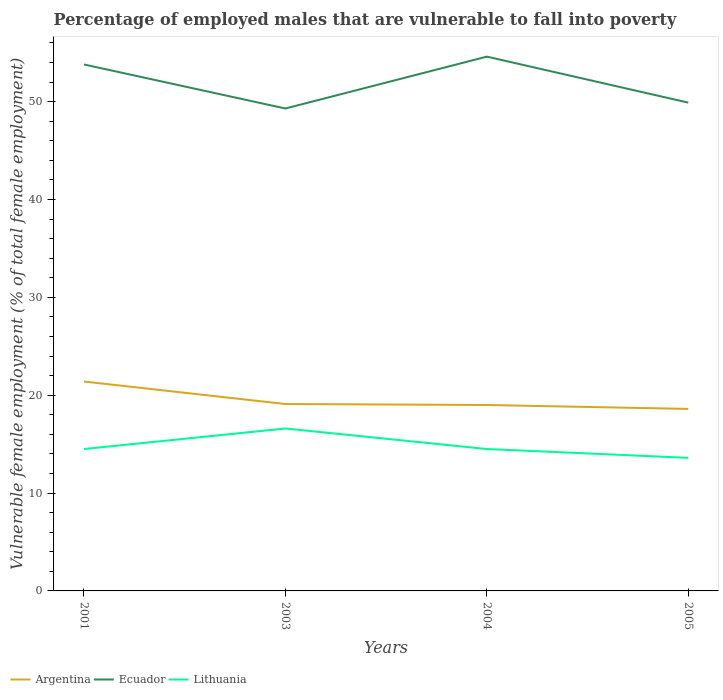Is the number of lines equal to the number of legend labels?
Make the answer very short. Yes. Across all years, what is the maximum percentage of employed males who are vulnerable to fall into poverty in Lithuania?
Your answer should be compact. 13.6. In which year was the percentage of employed males who are vulnerable to fall into poverty in Ecuador maximum?
Keep it short and to the point. 2003. What is the total percentage of employed males who are vulnerable to fall into poverty in Lithuania in the graph?
Keep it short and to the point. 0.9. What is the difference between the highest and the second highest percentage of employed males who are vulnerable to fall into poverty in Lithuania?
Your answer should be very brief. 3. What is the difference between the highest and the lowest percentage of employed males who are vulnerable to fall into poverty in Argentina?
Provide a short and direct response. 1. How many lines are there?
Your answer should be compact. 3. Does the graph contain grids?
Give a very brief answer. No. Where does the legend appear in the graph?
Your answer should be very brief. Bottom left. How are the legend labels stacked?
Provide a short and direct response. Horizontal. What is the title of the graph?
Offer a very short reply. Percentage of employed males that are vulnerable to fall into poverty. What is the label or title of the Y-axis?
Give a very brief answer. Vulnerable female employment (% of total female employment). What is the Vulnerable female employment (% of total female employment) of Argentina in 2001?
Offer a terse response. 21.4. What is the Vulnerable female employment (% of total female employment) in Ecuador in 2001?
Your response must be concise. 53.8. What is the Vulnerable female employment (% of total female employment) in Argentina in 2003?
Provide a short and direct response. 19.1. What is the Vulnerable female employment (% of total female employment) in Ecuador in 2003?
Provide a succinct answer. 49.3. What is the Vulnerable female employment (% of total female employment) in Lithuania in 2003?
Offer a terse response. 16.6. What is the Vulnerable female employment (% of total female employment) in Argentina in 2004?
Offer a very short reply. 19. What is the Vulnerable female employment (% of total female employment) of Ecuador in 2004?
Give a very brief answer. 54.6. What is the Vulnerable female employment (% of total female employment) in Lithuania in 2004?
Offer a terse response. 14.5. What is the Vulnerable female employment (% of total female employment) of Argentina in 2005?
Provide a short and direct response. 18.6. What is the Vulnerable female employment (% of total female employment) in Ecuador in 2005?
Provide a short and direct response. 49.9. What is the Vulnerable female employment (% of total female employment) of Lithuania in 2005?
Give a very brief answer. 13.6. Across all years, what is the maximum Vulnerable female employment (% of total female employment) in Argentina?
Ensure brevity in your answer.  21.4. Across all years, what is the maximum Vulnerable female employment (% of total female employment) in Ecuador?
Your response must be concise. 54.6. Across all years, what is the maximum Vulnerable female employment (% of total female employment) in Lithuania?
Keep it short and to the point. 16.6. Across all years, what is the minimum Vulnerable female employment (% of total female employment) in Argentina?
Your answer should be very brief. 18.6. Across all years, what is the minimum Vulnerable female employment (% of total female employment) of Ecuador?
Your response must be concise. 49.3. Across all years, what is the minimum Vulnerable female employment (% of total female employment) of Lithuania?
Provide a succinct answer. 13.6. What is the total Vulnerable female employment (% of total female employment) in Argentina in the graph?
Provide a succinct answer. 78.1. What is the total Vulnerable female employment (% of total female employment) of Ecuador in the graph?
Your response must be concise. 207.6. What is the total Vulnerable female employment (% of total female employment) of Lithuania in the graph?
Keep it short and to the point. 59.2. What is the difference between the Vulnerable female employment (% of total female employment) of Ecuador in 2001 and that in 2003?
Give a very brief answer. 4.5. What is the difference between the Vulnerable female employment (% of total female employment) of Argentina in 2001 and that in 2004?
Make the answer very short. 2.4. What is the difference between the Vulnerable female employment (% of total female employment) of Argentina in 2001 and that in 2005?
Make the answer very short. 2.8. What is the difference between the Vulnerable female employment (% of total female employment) in Ecuador in 2001 and that in 2005?
Offer a terse response. 3.9. What is the difference between the Vulnerable female employment (% of total female employment) of Lithuania in 2001 and that in 2005?
Give a very brief answer. 0.9. What is the difference between the Vulnerable female employment (% of total female employment) of Argentina in 2003 and that in 2004?
Your response must be concise. 0.1. What is the difference between the Vulnerable female employment (% of total female employment) in Lithuania in 2003 and that in 2004?
Provide a short and direct response. 2.1. What is the difference between the Vulnerable female employment (% of total female employment) of Argentina in 2003 and that in 2005?
Give a very brief answer. 0.5. What is the difference between the Vulnerable female employment (% of total female employment) in Ecuador in 2003 and that in 2005?
Give a very brief answer. -0.6. What is the difference between the Vulnerable female employment (% of total female employment) of Lithuania in 2003 and that in 2005?
Provide a short and direct response. 3. What is the difference between the Vulnerable female employment (% of total female employment) in Argentina in 2004 and that in 2005?
Offer a very short reply. 0.4. What is the difference between the Vulnerable female employment (% of total female employment) in Ecuador in 2004 and that in 2005?
Your answer should be compact. 4.7. What is the difference between the Vulnerable female employment (% of total female employment) of Lithuania in 2004 and that in 2005?
Your answer should be very brief. 0.9. What is the difference between the Vulnerable female employment (% of total female employment) in Argentina in 2001 and the Vulnerable female employment (% of total female employment) in Ecuador in 2003?
Your answer should be compact. -27.9. What is the difference between the Vulnerable female employment (% of total female employment) of Ecuador in 2001 and the Vulnerable female employment (% of total female employment) of Lithuania in 2003?
Your answer should be compact. 37.2. What is the difference between the Vulnerable female employment (% of total female employment) in Argentina in 2001 and the Vulnerable female employment (% of total female employment) in Ecuador in 2004?
Make the answer very short. -33.2. What is the difference between the Vulnerable female employment (% of total female employment) in Ecuador in 2001 and the Vulnerable female employment (% of total female employment) in Lithuania in 2004?
Provide a short and direct response. 39.3. What is the difference between the Vulnerable female employment (% of total female employment) in Argentina in 2001 and the Vulnerable female employment (% of total female employment) in Ecuador in 2005?
Offer a very short reply. -28.5. What is the difference between the Vulnerable female employment (% of total female employment) in Ecuador in 2001 and the Vulnerable female employment (% of total female employment) in Lithuania in 2005?
Ensure brevity in your answer.  40.2. What is the difference between the Vulnerable female employment (% of total female employment) in Argentina in 2003 and the Vulnerable female employment (% of total female employment) in Ecuador in 2004?
Provide a short and direct response. -35.5. What is the difference between the Vulnerable female employment (% of total female employment) of Argentina in 2003 and the Vulnerable female employment (% of total female employment) of Lithuania in 2004?
Ensure brevity in your answer.  4.6. What is the difference between the Vulnerable female employment (% of total female employment) of Ecuador in 2003 and the Vulnerable female employment (% of total female employment) of Lithuania in 2004?
Ensure brevity in your answer.  34.8. What is the difference between the Vulnerable female employment (% of total female employment) in Argentina in 2003 and the Vulnerable female employment (% of total female employment) in Ecuador in 2005?
Keep it short and to the point. -30.8. What is the difference between the Vulnerable female employment (% of total female employment) in Argentina in 2003 and the Vulnerable female employment (% of total female employment) in Lithuania in 2005?
Provide a succinct answer. 5.5. What is the difference between the Vulnerable female employment (% of total female employment) of Ecuador in 2003 and the Vulnerable female employment (% of total female employment) of Lithuania in 2005?
Provide a succinct answer. 35.7. What is the difference between the Vulnerable female employment (% of total female employment) of Argentina in 2004 and the Vulnerable female employment (% of total female employment) of Ecuador in 2005?
Keep it short and to the point. -30.9. What is the difference between the Vulnerable female employment (% of total female employment) in Argentina in 2004 and the Vulnerable female employment (% of total female employment) in Lithuania in 2005?
Offer a terse response. 5.4. What is the average Vulnerable female employment (% of total female employment) in Argentina per year?
Ensure brevity in your answer.  19.52. What is the average Vulnerable female employment (% of total female employment) of Ecuador per year?
Keep it short and to the point. 51.9. What is the average Vulnerable female employment (% of total female employment) in Lithuania per year?
Make the answer very short. 14.8. In the year 2001, what is the difference between the Vulnerable female employment (% of total female employment) in Argentina and Vulnerable female employment (% of total female employment) in Ecuador?
Offer a terse response. -32.4. In the year 2001, what is the difference between the Vulnerable female employment (% of total female employment) of Ecuador and Vulnerable female employment (% of total female employment) of Lithuania?
Your answer should be compact. 39.3. In the year 2003, what is the difference between the Vulnerable female employment (% of total female employment) in Argentina and Vulnerable female employment (% of total female employment) in Ecuador?
Offer a very short reply. -30.2. In the year 2003, what is the difference between the Vulnerable female employment (% of total female employment) of Ecuador and Vulnerable female employment (% of total female employment) of Lithuania?
Offer a very short reply. 32.7. In the year 2004, what is the difference between the Vulnerable female employment (% of total female employment) in Argentina and Vulnerable female employment (% of total female employment) in Ecuador?
Your answer should be very brief. -35.6. In the year 2004, what is the difference between the Vulnerable female employment (% of total female employment) in Ecuador and Vulnerable female employment (% of total female employment) in Lithuania?
Offer a very short reply. 40.1. In the year 2005, what is the difference between the Vulnerable female employment (% of total female employment) in Argentina and Vulnerable female employment (% of total female employment) in Ecuador?
Make the answer very short. -31.3. In the year 2005, what is the difference between the Vulnerable female employment (% of total female employment) in Ecuador and Vulnerable female employment (% of total female employment) in Lithuania?
Provide a short and direct response. 36.3. What is the ratio of the Vulnerable female employment (% of total female employment) of Argentina in 2001 to that in 2003?
Offer a very short reply. 1.12. What is the ratio of the Vulnerable female employment (% of total female employment) in Ecuador in 2001 to that in 2003?
Make the answer very short. 1.09. What is the ratio of the Vulnerable female employment (% of total female employment) in Lithuania in 2001 to that in 2003?
Provide a succinct answer. 0.87. What is the ratio of the Vulnerable female employment (% of total female employment) in Argentina in 2001 to that in 2004?
Give a very brief answer. 1.13. What is the ratio of the Vulnerable female employment (% of total female employment) in Ecuador in 2001 to that in 2004?
Give a very brief answer. 0.99. What is the ratio of the Vulnerable female employment (% of total female employment) of Lithuania in 2001 to that in 2004?
Provide a succinct answer. 1. What is the ratio of the Vulnerable female employment (% of total female employment) of Argentina in 2001 to that in 2005?
Offer a terse response. 1.15. What is the ratio of the Vulnerable female employment (% of total female employment) of Ecuador in 2001 to that in 2005?
Offer a terse response. 1.08. What is the ratio of the Vulnerable female employment (% of total female employment) in Lithuania in 2001 to that in 2005?
Ensure brevity in your answer.  1.07. What is the ratio of the Vulnerable female employment (% of total female employment) of Argentina in 2003 to that in 2004?
Make the answer very short. 1.01. What is the ratio of the Vulnerable female employment (% of total female employment) in Ecuador in 2003 to that in 2004?
Offer a terse response. 0.9. What is the ratio of the Vulnerable female employment (% of total female employment) in Lithuania in 2003 to that in 2004?
Your response must be concise. 1.14. What is the ratio of the Vulnerable female employment (% of total female employment) in Argentina in 2003 to that in 2005?
Provide a succinct answer. 1.03. What is the ratio of the Vulnerable female employment (% of total female employment) in Lithuania in 2003 to that in 2005?
Provide a succinct answer. 1.22. What is the ratio of the Vulnerable female employment (% of total female employment) of Argentina in 2004 to that in 2005?
Provide a short and direct response. 1.02. What is the ratio of the Vulnerable female employment (% of total female employment) of Ecuador in 2004 to that in 2005?
Offer a terse response. 1.09. What is the ratio of the Vulnerable female employment (% of total female employment) of Lithuania in 2004 to that in 2005?
Offer a very short reply. 1.07. What is the difference between the highest and the second highest Vulnerable female employment (% of total female employment) of Ecuador?
Your response must be concise. 0.8. What is the difference between the highest and the second highest Vulnerable female employment (% of total female employment) in Lithuania?
Provide a succinct answer. 2.1. What is the difference between the highest and the lowest Vulnerable female employment (% of total female employment) of Argentina?
Keep it short and to the point. 2.8. 